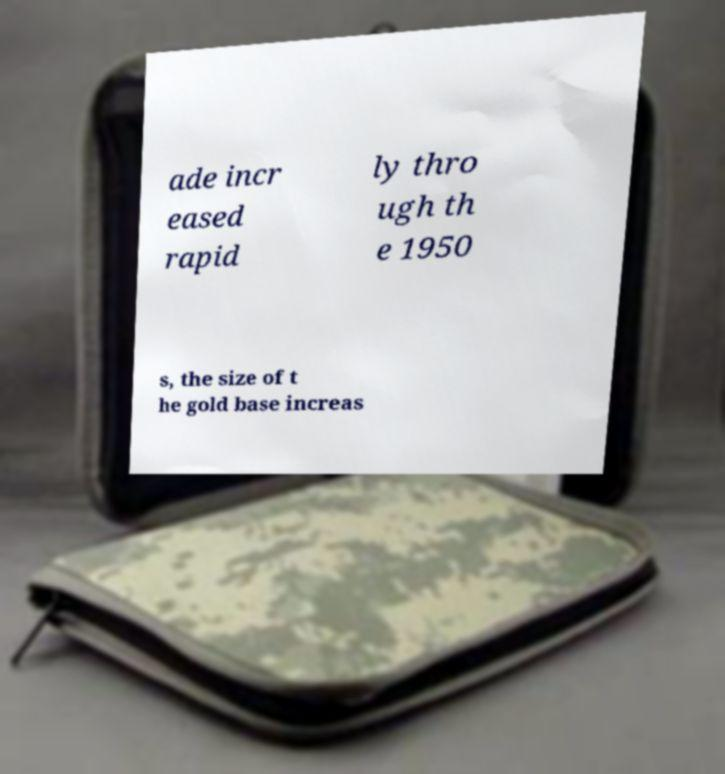Please read and relay the text visible in this image. What does it say? ade incr eased rapid ly thro ugh th e 1950 s, the size of t he gold base increas 